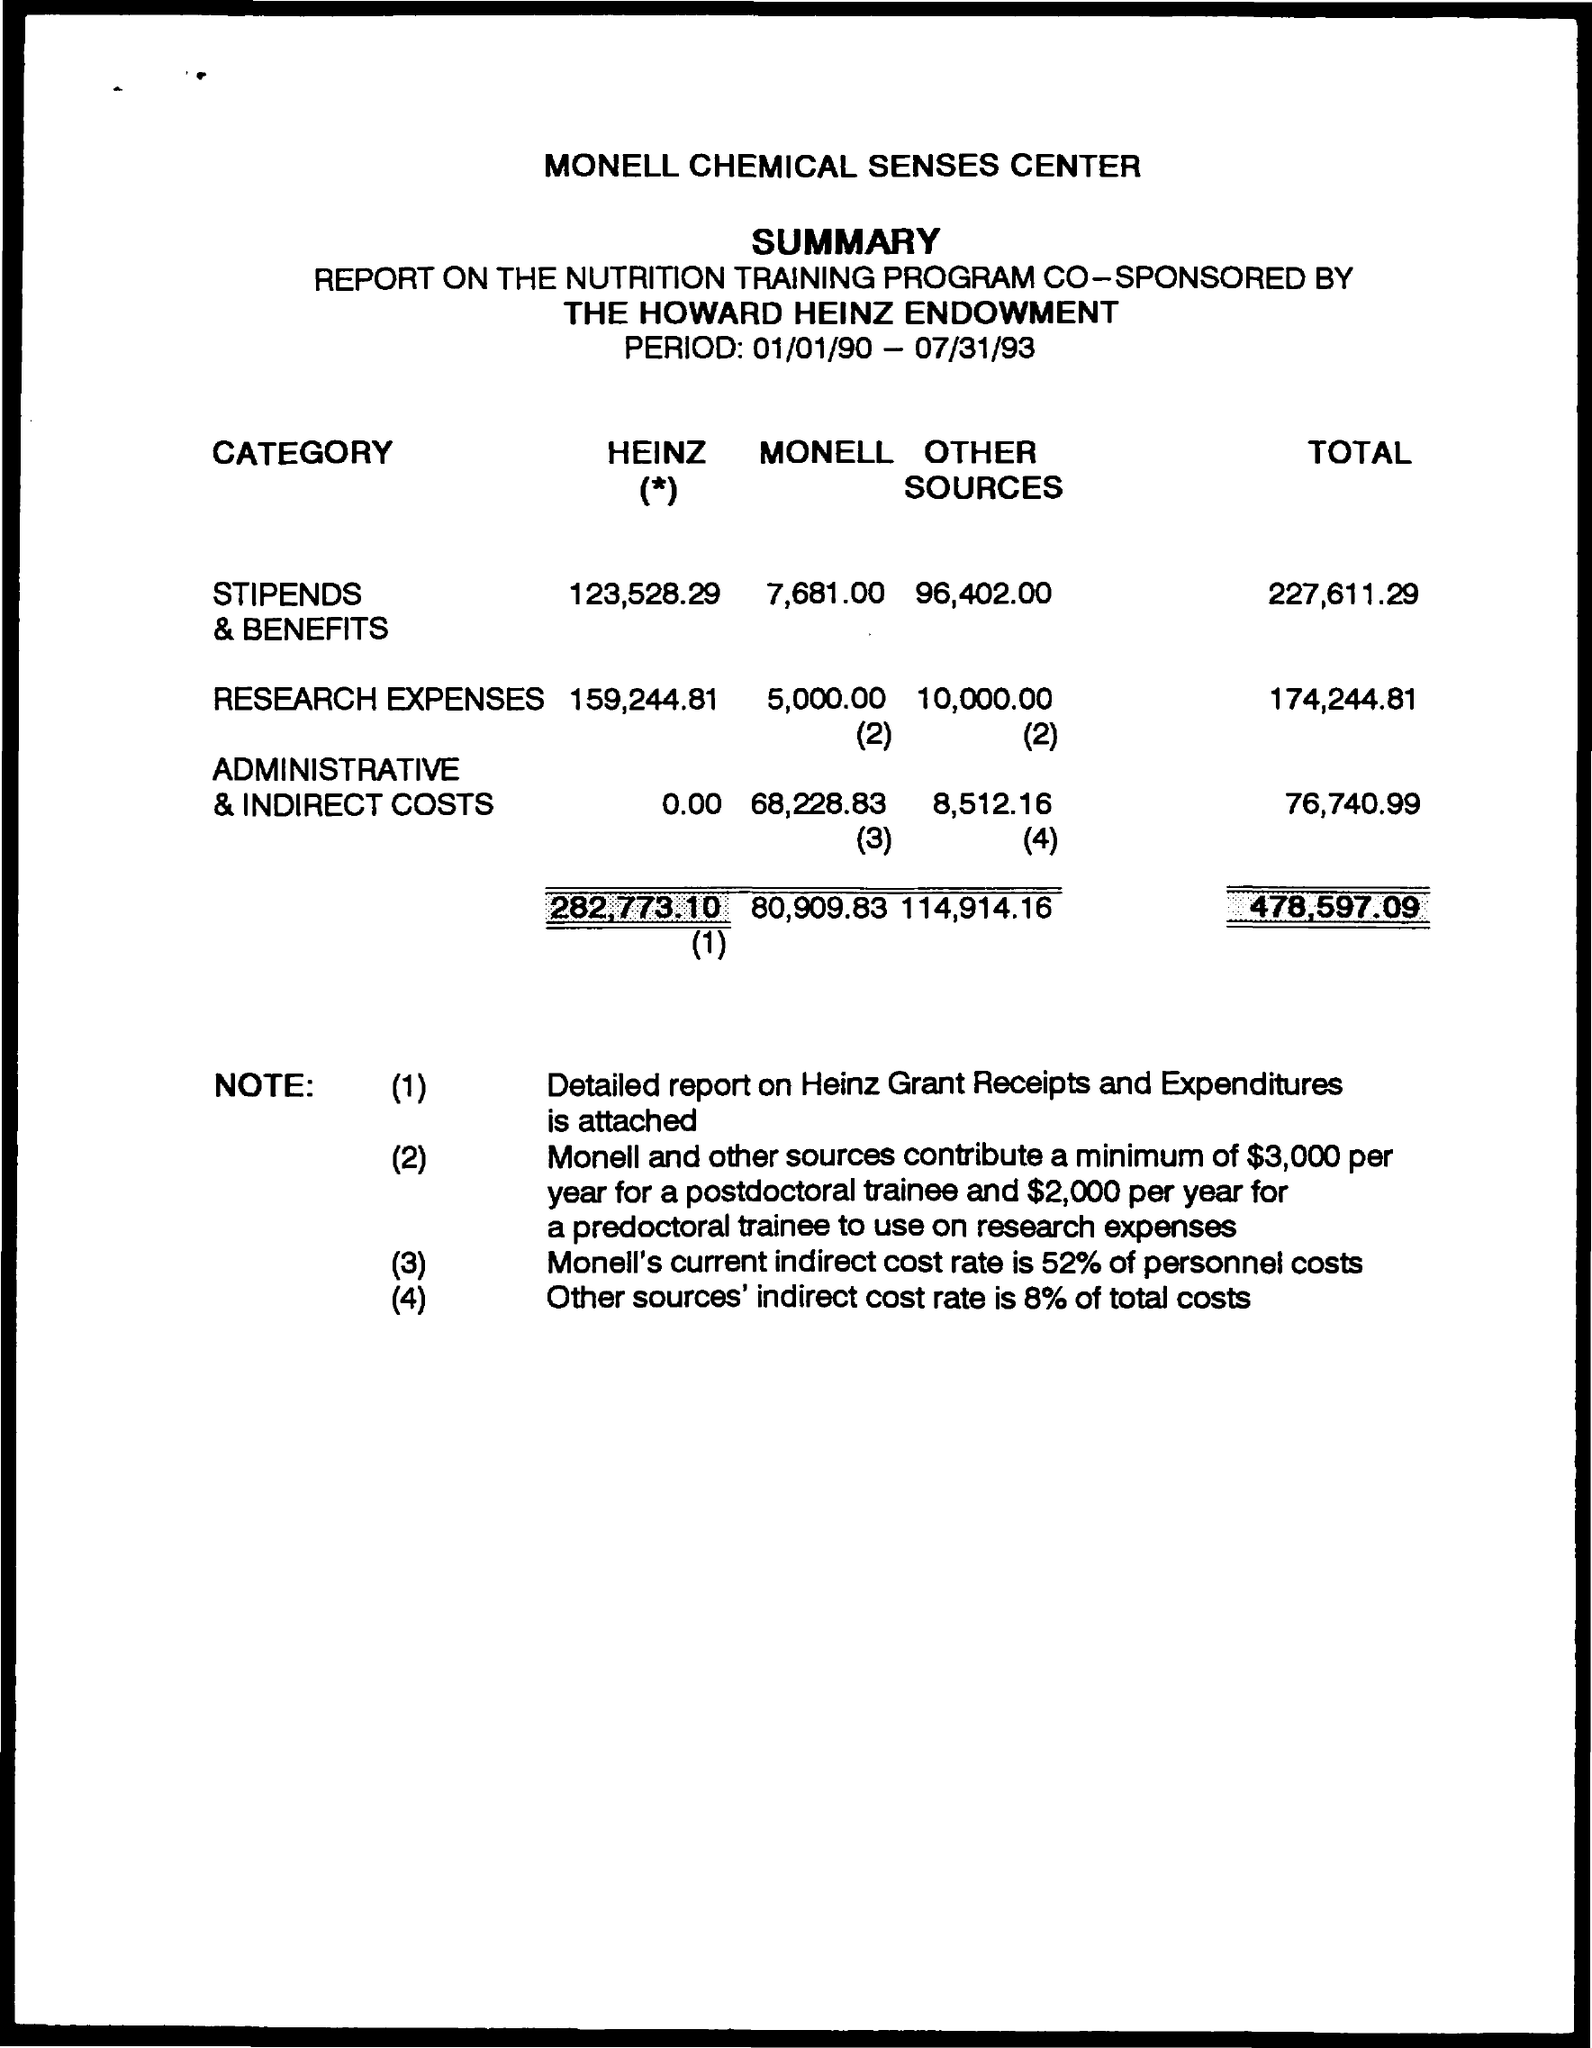Mention a couple of crucial points in this snapshot. I am attaching a detailed report on "What" along with this document. The report is titled "Heinz Grant Receipts and Expenditures. I'm sorry, the input you provided is not a complete question or request. Can you please provide me with more information or context so I can better understand what you need help with? The period duration is from January 1, 1990 to July 31, 1993. The indirect cost rate taken for other sources is 8% of the total cost. The total cost of "Heinz" is 282,773.10. 